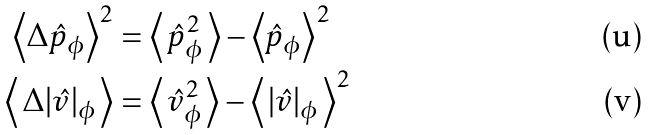Convert formula to latex. <formula><loc_0><loc_0><loc_500><loc_500>\left < \Delta { \hat { p } _ { \phi } } \right > ^ { 2 } & = \left < \, { \hat { p } _ { \phi } ^ { 2 } } \, \right > - \left < { \hat { p } _ { \phi } } \right > ^ { 2 } \\ \left < \, \Delta { | \hat { v } | _ { \phi } } \, \right > & = \left < \, { \hat { v } ^ { 2 } _ { \phi } } \, \right > - \left < \, { | \hat { v } | _ { \phi } } \, \right > ^ { 2 }</formula> 